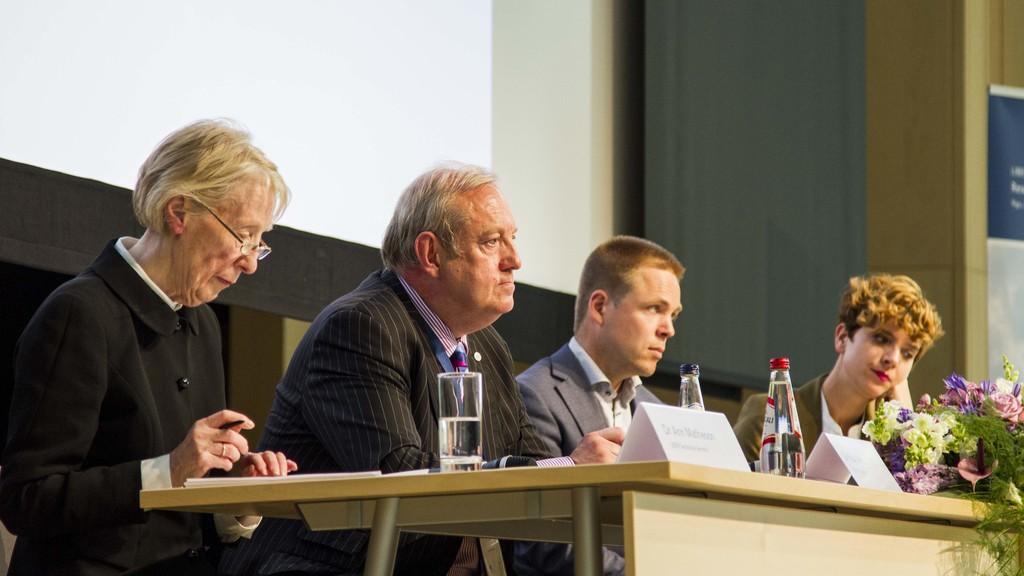In one or two sentences, can you explain what this image depicts? In this picture here is a table a water bottle on it. and here is a water glass, and here is a person wearing glasses holding a pen in hand, with some papers and here is person wearing a suit. here is a person sitting on a chair ,here is woman sitting, and beside her there are bunch of flowers. 